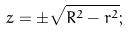<formula> <loc_0><loc_0><loc_500><loc_500>z = \pm \sqrt { R ^ { 2 } - r ^ { 2 } } ;</formula> 